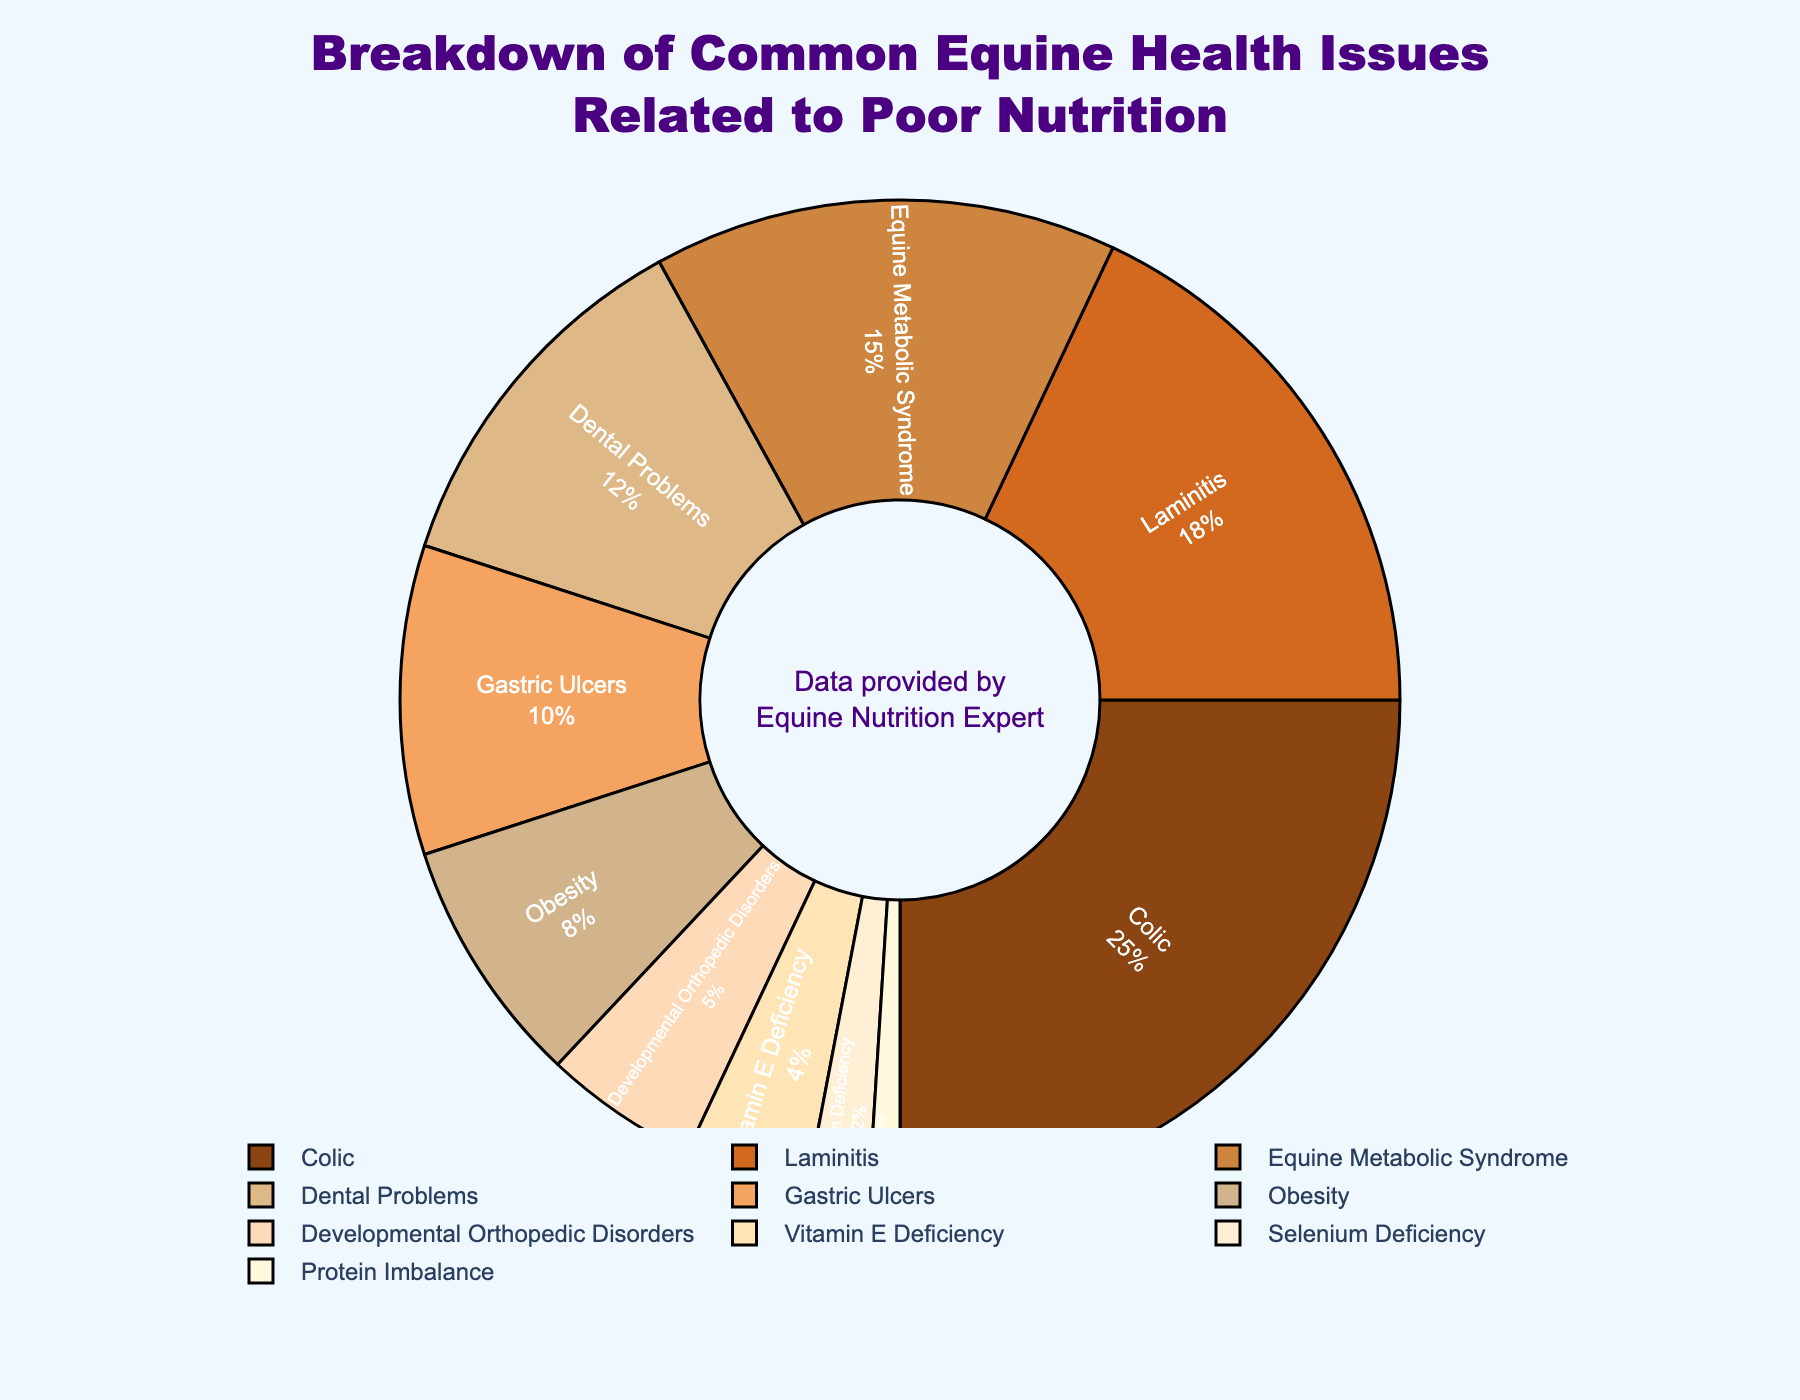Which health issue has the highest percentage? The largest segment in the pie chart is identified by the color and label, which indicates it represents 25% of the data. The label on this segment is "Colic".
Answer: Colic What value distinguishes Laminitis from Protein Imbalance? Laminitis has an 18% share in the pie chart, whereas Protein Imbalance has a 1% share. The difference between these values is 18% - 1% = 17%.
Answer: 17% Compare the combined percentage of Dental Problems and Gastric Ulcers to Colic. Which is higher? Dental Problems has a value of 12%, and Gastric Ulcers has 10%. Combined, these equal 12% + 10% = 22%. Colic has a value of 25%. Therefore, 25% (Colic) is higher than 22% (Dental Problems and Gastric Ulcers combined).
Answer: Colic By how much does the percentage of Equine Metabolic Syndrome exceed that of Obesity? Equine Metabolic Syndrome has a percentage of 15%, and Obesity is at 8%. Calculating the difference: 15% - 8% = 7%.
Answer: 7% Which health issues together account for less than 10% of the total? The segments with percentages less than 10% are Obesity (8%), Developmental Orthopedic Disorders (5%), Vitamin E Deficiency (4%), Selenium Deficiency (2%), and Protein Imbalance (1%).
Answer: Obesity, Developmental Orthopedic Disorders, Vitamin E Deficiency, Selenium Deficiency, Protein Imbalance What are the three least common health issues? Identify the three smallest segments on the pie chart: Protein Imbalance (1%), Selenium Deficiency (2%), and Vitamin E Deficiency (4%).
Answer: Protein Imbalance, Selenium Deficiency, Vitamin E Deficiency Which color represents the issue associated with 10%? Locate the 10% segment on the pie chart and note its color, which matches the label "Gastric Ulcers". The segment is colored tan.
Answer: tan Sum up the percentage of Developmental Orthopedic Disorders and Vitamin E Deficiency. Developmental Orthopedic Disorders account for 5%, and Vitamin E Deficiency for 4%. Summing these values gives 5% + 4% = 9%.
Answer: 9% What percentage do the top three health issues constitute together? The top three health issues are Colic (25%), Laminitis (18%), and Equine Metabolic Syndrome (15%). Their combined percentage is 25% + 18% + 15% = 58%.
Answer: 58% Determine the average percentage of health issues related to poor nutrition listed, given there are 10 distinct issues. Add all the percentages: 25% + 18% + 15% + 12% + 10% + 8% + 5% + 4% + 2% + 1%, which equals 100%. Divide by 10 issues: 100% / 10 = 10%.
Answer: 10% 